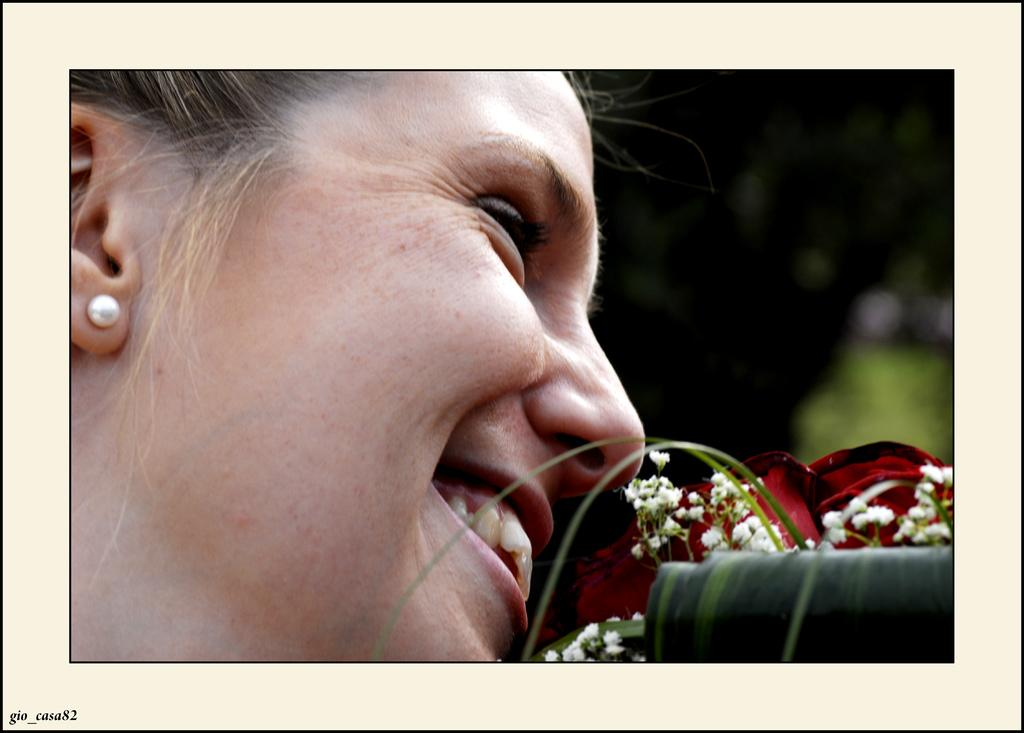Who is present in the image? There is a woman in the image. What is in front of the woman's face? There are rose flowers in front of the woman's face. Can you tell if the image has been altered in any way? Yes, the image has been edited. How many cherries are on the woman's head in the image? There are no cherries present on the woman's head in the image. What type of art is the woman creating in the image? The image does not show the woman creating any art. 